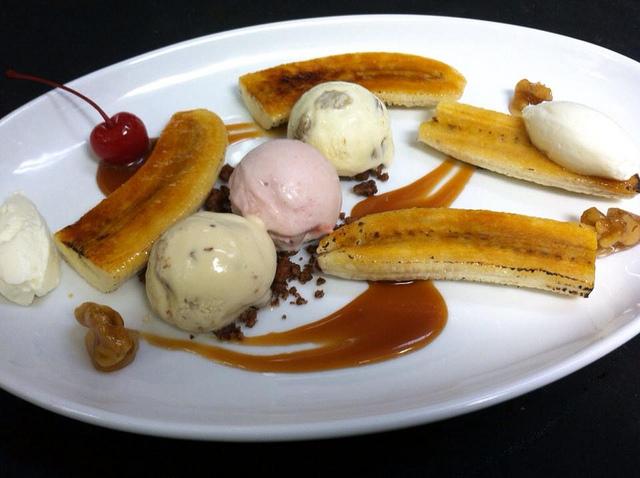Would this taste sweet?
Concise answer only. Yes. How many pieces of banana are on this plate?
Keep it brief. 4. What has a stem?
Quick response, please. Cherry. 